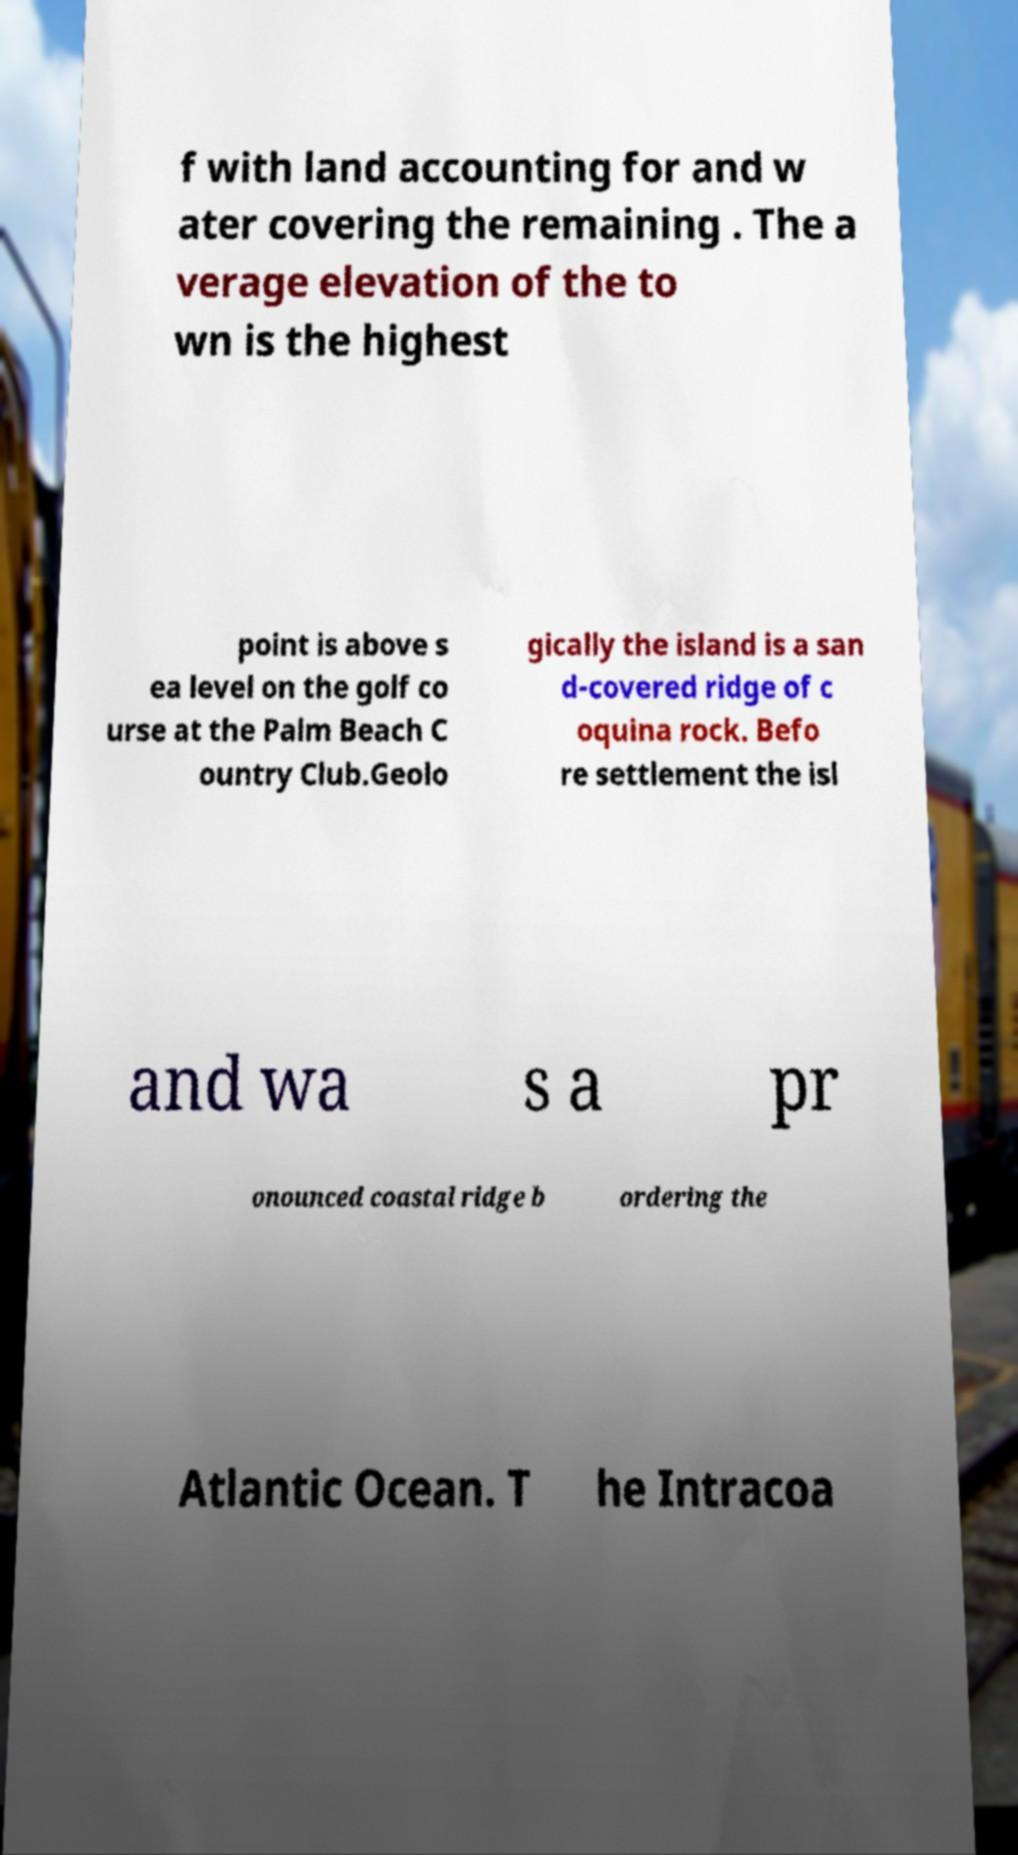Could you assist in decoding the text presented in this image and type it out clearly? f with land accounting for and w ater covering the remaining . The a verage elevation of the to wn is the highest point is above s ea level on the golf co urse at the Palm Beach C ountry Club.Geolo gically the island is a san d-covered ridge of c oquina rock. Befo re settlement the isl and wa s a pr onounced coastal ridge b ordering the Atlantic Ocean. T he Intracoa 